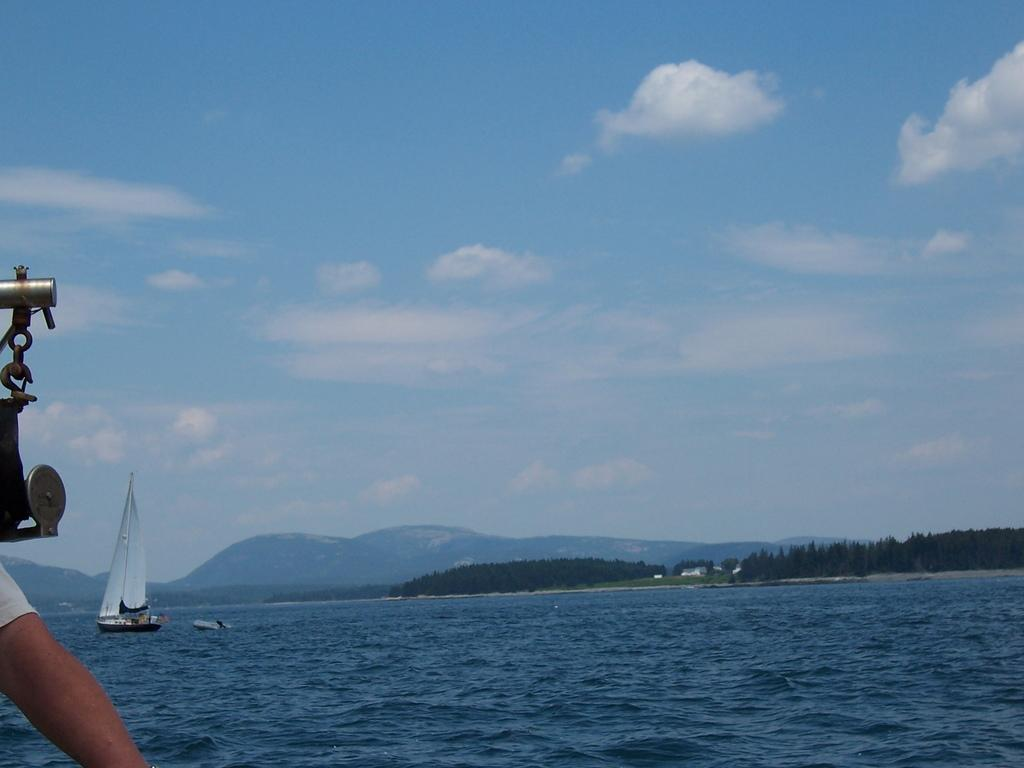What can be seen on the left side of the image? There is a hand of a person and metal rods on the left side of the image. What is visible in the background of the image? There are trees, clouds, hills, and a boat on the water in the background of the image. What type of rose is being held by the person in the image? There is no rose present in the image; only a hand and metal rods are visible on the left side. How many leaves can be seen on the trees in the background of the image? The image does not provide enough detail to count the number of leaves on the trees in the background. 